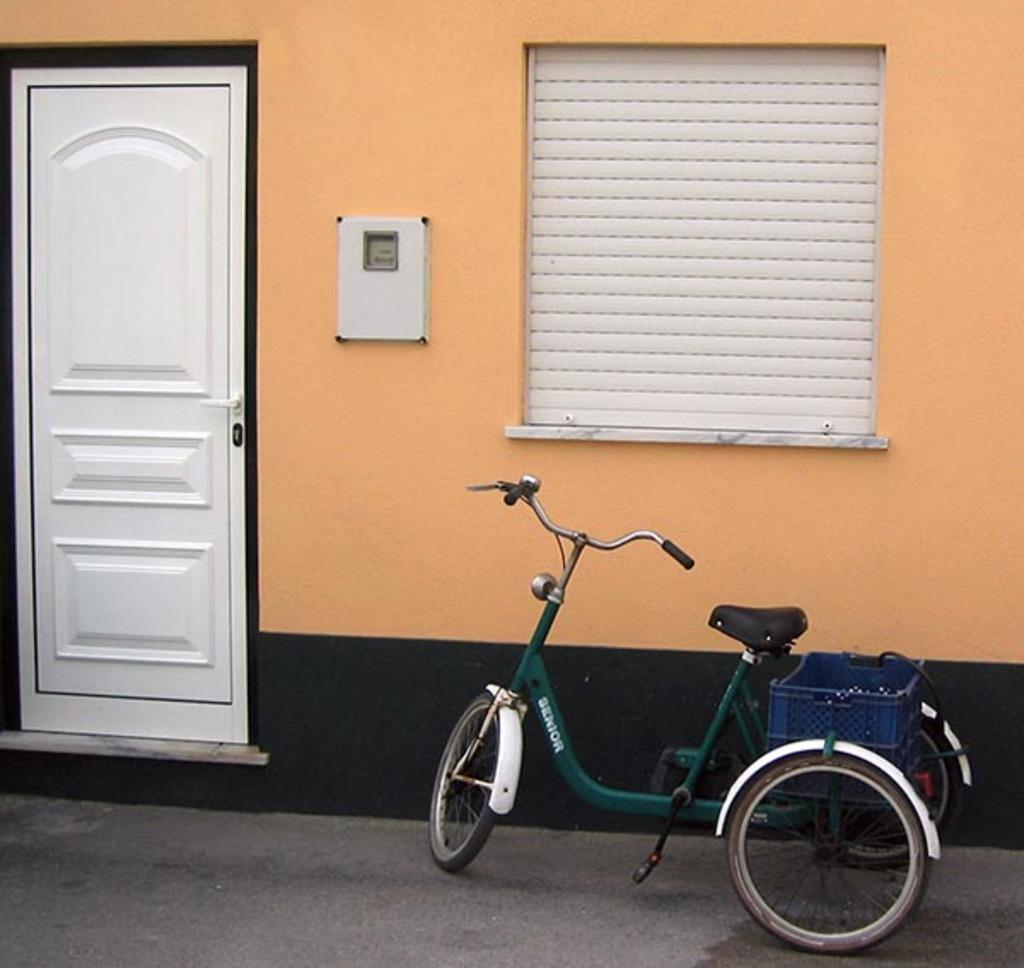Can you describe this image briefly? In this image we can see a door, a window with window shade and a box to the wall, there is a vehicle on the road. 